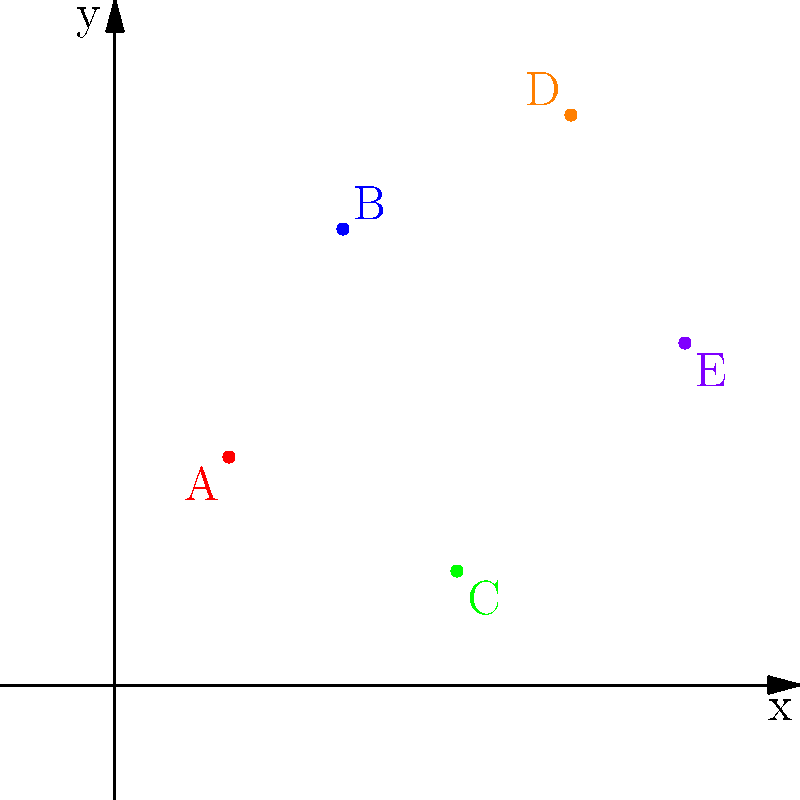In Miguel Berzal de Miguel's novel "El laberinto de los espejos," there's a scene where the protagonist discovers a hidden map with mysterious coordinates. To unlock the map's secret, you must plot these points on a Cartesian plane: A(1,2), B(2,4), C(3,1), D(4,5), and E(5,3). Once plotted, the shape formed by connecting these points in alphabetical order represents a symbolic object in the story. What letter of the alphabet does this shape most closely resemble? To solve this problem, we need to follow these steps:

1. Plot the given points on the Cartesian plane:
   A(1,2), B(2,4), C(3,1), D(4,5), and E(5,3)

2. Connect the points in alphabetical order:
   A → B → C → D → E

3. Analyze the resulting shape:
   - From A to B, we have an upward diagonal line
   - From B to C, we have a downward diagonal line
   - From C to D, we have a steep upward diagonal line
   - From D to E, we have a downward diagonal line

4. Observe the overall shape:
   The resulting figure resembles a zigzag pattern that, when viewed as a whole, looks most similar to the letter "M".

5. Interpret the symbolism:
   In "El laberinto de los espejos," the letter "M" could symbolize various themes such as "Misterio" (Mystery), "Memoria" (Memory), or even "Miguel" (a possible reference to the author himself), which are common motifs in Berzal de Miguel's works.
Answer: M 